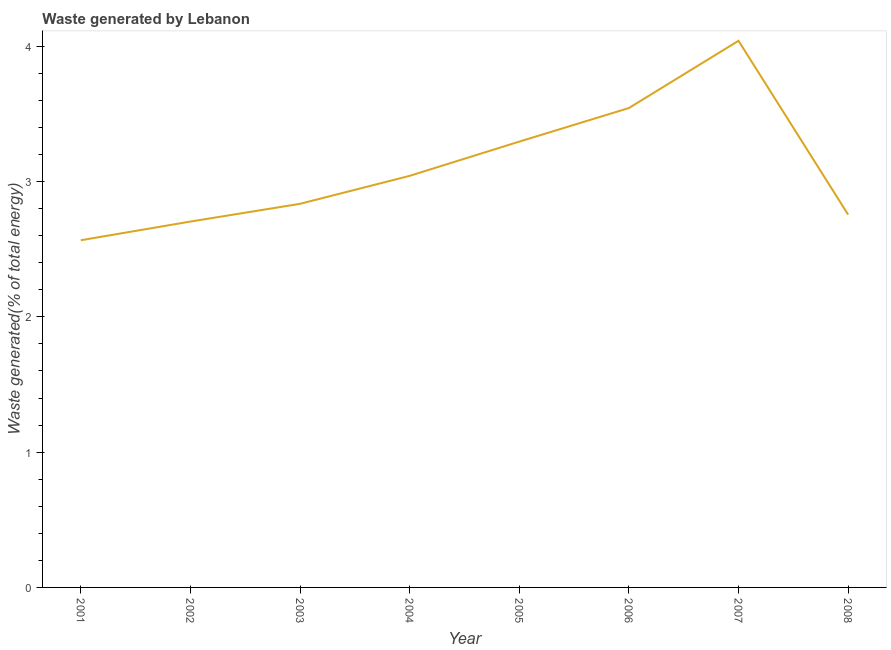What is the amount of waste generated in 2005?
Make the answer very short. 3.3. Across all years, what is the maximum amount of waste generated?
Offer a terse response. 4.04. Across all years, what is the minimum amount of waste generated?
Offer a very short reply. 2.57. In which year was the amount of waste generated maximum?
Make the answer very short. 2007. In which year was the amount of waste generated minimum?
Your response must be concise. 2001. What is the sum of the amount of waste generated?
Your answer should be very brief. 24.78. What is the difference between the amount of waste generated in 2003 and 2004?
Your answer should be very brief. -0.21. What is the average amount of waste generated per year?
Your response must be concise. 3.1. What is the median amount of waste generated?
Make the answer very short. 2.94. In how many years, is the amount of waste generated greater than 3.2 %?
Give a very brief answer. 3. Do a majority of the years between 2001 and 2005 (inclusive) have amount of waste generated greater than 2.8 %?
Provide a succinct answer. Yes. What is the ratio of the amount of waste generated in 2002 to that in 2003?
Provide a succinct answer. 0.95. What is the difference between the highest and the second highest amount of waste generated?
Keep it short and to the point. 0.5. What is the difference between the highest and the lowest amount of waste generated?
Provide a short and direct response. 1.47. In how many years, is the amount of waste generated greater than the average amount of waste generated taken over all years?
Your answer should be compact. 3. How many years are there in the graph?
Provide a succinct answer. 8. Does the graph contain any zero values?
Provide a short and direct response. No. Does the graph contain grids?
Offer a very short reply. No. What is the title of the graph?
Keep it short and to the point. Waste generated by Lebanon. What is the label or title of the Y-axis?
Offer a terse response. Waste generated(% of total energy). What is the Waste generated(% of total energy) of 2001?
Your response must be concise. 2.57. What is the Waste generated(% of total energy) in 2002?
Your response must be concise. 2.7. What is the Waste generated(% of total energy) in 2003?
Keep it short and to the point. 2.84. What is the Waste generated(% of total energy) in 2004?
Provide a succinct answer. 3.04. What is the Waste generated(% of total energy) in 2005?
Provide a succinct answer. 3.3. What is the Waste generated(% of total energy) of 2006?
Keep it short and to the point. 3.54. What is the Waste generated(% of total energy) in 2007?
Give a very brief answer. 4.04. What is the Waste generated(% of total energy) of 2008?
Make the answer very short. 2.76. What is the difference between the Waste generated(% of total energy) in 2001 and 2002?
Ensure brevity in your answer.  -0.14. What is the difference between the Waste generated(% of total energy) in 2001 and 2003?
Ensure brevity in your answer.  -0.27. What is the difference between the Waste generated(% of total energy) in 2001 and 2004?
Your answer should be compact. -0.48. What is the difference between the Waste generated(% of total energy) in 2001 and 2005?
Offer a very short reply. -0.73. What is the difference between the Waste generated(% of total energy) in 2001 and 2006?
Ensure brevity in your answer.  -0.98. What is the difference between the Waste generated(% of total energy) in 2001 and 2007?
Your answer should be very brief. -1.47. What is the difference between the Waste generated(% of total energy) in 2001 and 2008?
Provide a succinct answer. -0.19. What is the difference between the Waste generated(% of total energy) in 2002 and 2003?
Give a very brief answer. -0.13. What is the difference between the Waste generated(% of total energy) in 2002 and 2004?
Provide a short and direct response. -0.34. What is the difference between the Waste generated(% of total energy) in 2002 and 2005?
Your answer should be compact. -0.59. What is the difference between the Waste generated(% of total energy) in 2002 and 2006?
Your response must be concise. -0.84. What is the difference between the Waste generated(% of total energy) in 2002 and 2007?
Ensure brevity in your answer.  -1.34. What is the difference between the Waste generated(% of total energy) in 2002 and 2008?
Provide a succinct answer. -0.05. What is the difference between the Waste generated(% of total energy) in 2003 and 2004?
Your response must be concise. -0.21. What is the difference between the Waste generated(% of total energy) in 2003 and 2005?
Keep it short and to the point. -0.46. What is the difference between the Waste generated(% of total energy) in 2003 and 2006?
Your response must be concise. -0.71. What is the difference between the Waste generated(% of total energy) in 2003 and 2007?
Offer a terse response. -1.2. What is the difference between the Waste generated(% of total energy) in 2003 and 2008?
Provide a succinct answer. 0.08. What is the difference between the Waste generated(% of total energy) in 2004 and 2005?
Make the answer very short. -0.25. What is the difference between the Waste generated(% of total energy) in 2004 and 2006?
Ensure brevity in your answer.  -0.5. What is the difference between the Waste generated(% of total energy) in 2004 and 2007?
Provide a succinct answer. -1. What is the difference between the Waste generated(% of total energy) in 2004 and 2008?
Your answer should be very brief. 0.29. What is the difference between the Waste generated(% of total energy) in 2005 and 2006?
Offer a very short reply. -0.25. What is the difference between the Waste generated(% of total energy) in 2005 and 2007?
Keep it short and to the point. -0.75. What is the difference between the Waste generated(% of total energy) in 2005 and 2008?
Your answer should be very brief. 0.54. What is the difference between the Waste generated(% of total energy) in 2006 and 2007?
Offer a very short reply. -0.5. What is the difference between the Waste generated(% of total energy) in 2006 and 2008?
Your answer should be compact. 0.79. What is the difference between the Waste generated(% of total energy) in 2007 and 2008?
Offer a terse response. 1.28. What is the ratio of the Waste generated(% of total energy) in 2001 to that in 2002?
Offer a very short reply. 0.95. What is the ratio of the Waste generated(% of total energy) in 2001 to that in 2003?
Offer a terse response. 0.91. What is the ratio of the Waste generated(% of total energy) in 2001 to that in 2004?
Ensure brevity in your answer.  0.84. What is the ratio of the Waste generated(% of total energy) in 2001 to that in 2005?
Your answer should be very brief. 0.78. What is the ratio of the Waste generated(% of total energy) in 2001 to that in 2006?
Provide a short and direct response. 0.72. What is the ratio of the Waste generated(% of total energy) in 2001 to that in 2007?
Ensure brevity in your answer.  0.64. What is the ratio of the Waste generated(% of total energy) in 2001 to that in 2008?
Your answer should be compact. 0.93. What is the ratio of the Waste generated(% of total energy) in 2002 to that in 2003?
Give a very brief answer. 0.95. What is the ratio of the Waste generated(% of total energy) in 2002 to that in 2004?
Your answer should be very brief. 0.89. What is the ratio of the Waste generated(% of total energy) in 2002 to that in 2005?
Provide a succinct answer. 0.82. What is the ratio of the Waste generated(% of total energy) in 2002 to that in 2006?
Make the answer very short. 0.76. What is the ratio of the Waste generated(% of total energy) in 2002 to that in 2007?
Your response must be concise. 0.67. What is the ratio of the Waste generated(% of total energy) in 2002 to that in 2008?
Provide a succinct answer. 0.98. What is the ratio of the Waste generated(% of total energy) in 2003 to that in 2004?
Provide a short and direct response. 0.93. What is the ratio of the Waste generated(% of total energy) in 2003 to that in 2005?
Offer a very short reply. 0.86. What is the ratio of the Waste generated(% of total energy) in 2003 to that in 2007?
Provide a succinct answer. 0.7. What is the ratio of the Waste generated(% of total energy) in 2003 to that in 2008?
Ensure brevity in your answer.  1.03. What is the ratio of the Waste generated(% of total energy) in 2004 to that in 2005?
Give a very brief answer. 0.92. What is the ratio of the Waste generated(% of total energy) in 2004 to that in 2006?
Keep it short and to the point. 0.86. What is the ratio of the Waste generated(% of total energy) in 2004 to that in 2007?
Your response must be concise. 0.75. What is the ratio of the Waste generated(% of total energy) in 2004 to that in 2008?
Keep it short and to the point. 1.1. What is the ratio of the Waste generated(% of total energy) in 2005 to that in 2006?
Ensure brevity in your answer.  0.93. What is the ratio of the Waste generated(% of total energy) in 2005 to that in 2007?
Make the answer very short. 0.82. What is the ratio of the Waste generated(% of total energy) in 2005 to that in 2008?
Ensure brevity in your answer.  1.2. What is the ratio of the Waste generated(% of total energy) in 2006 to that in 2007?
Your answer should be compact. 0.88. What is the ratio of the Waste generated(% of total energy) in 2006 to that in 2008?
Keep it short and to the point. 1.29. What is the ratio of the Waste generated(% of total energy) in 2007 to that in 2008?
Offer a terse response. 1.47. 